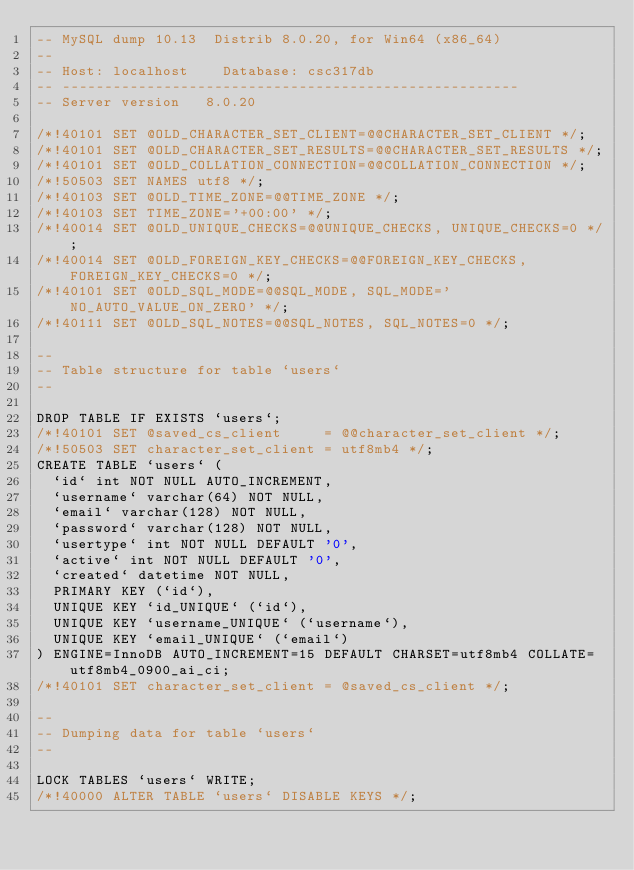Convert code to text. <code><loc_0><loc_0><loc_500><loc_500><_SQL_>-- MySQL dump 10.13  Distrib 8.0.20, for Win64 (x86_64)
--
-- Host: localhost    Database: csc317db
-- ------------------------------------------------------
-- Server version	8.0.20

/*!40101 SET @OLD_CHARACTER_SET_CLIENT=@@CHARACTER_SET_CLIENT */;
/*!40101 SET @OLD_CHARACTER_SET_RESULTS=@@CHARACTER_SET_RESULTS */;
/*!40101 SET @OLD_COLLATION_CONNECTION=@@COLLATION_CONNECTION */;
/*!50503 SET NAMES utf8 */;
/*!40103 SET @OLD_TIME_ZONE=@@TIME_ZONE */;
/*!40103 SET TIME_ZONE='+00:00' */;
/*!40014 SET @OLD_UNIQUE_CHECKS=@@UNIQUE_CHECKS, UNIQUE_CHECKS=0 */;
/*!40014 SET @OLD_FOREIGN_KEY_CHECKS=@@FOREIGN_KEY_CHECKS, FOREIGN_KEY_CHECKS=0 */;
/*!40101 SET @OLD_SQL_MODE=@@SQL_MODE, SQL_MODE='NO_AUTO_VALUE_ON_ZERO' */;
/*!40111 SET @OLD_SQL_NOTES=@@SQL_NOTES, SQL_NOTES=0 */;

--
-- Table structure for table `users`
--

DROP TABLE IF EXISTS `users`;
/*!40101 SET @saved_cs_client     = @@character_set_client */;
/*!50503 SET character_set_client = utf8mb4 */;
CREATE TABLE `users` (
  `id` int NOT NULL AUTO_INCREMENT,
  `username` varchar(64) NOT NULL,
  `email` varchar(128) NOT NULL,
  `password` varchar(128) NOT NULL,
  `usertype` int NOT NULL DEFAULT '0',
  `active` int NOT NULL DEFAULT '0',
  `created` datetime NOT NULL,
  PRIMARY KEY (`id`),
  UNIQUE KEY `id_UNIQUE` (`id`),
  UNIQUE KEY `username_UNIQUE` (`username`),
  UNIQUE KEY `email_UNIQUE` (`email`)
) ENGINE=InnoDB AUTO_INCREMENT=15 DEFAULT CHARSET=utf8mb4 COLLATE=utf8mb4_0900_ai_ci;
/*!40101 SET character_set_client = @saved_cs_client */;

--
-- Dumping data for table `users`
--

LOCK TABLES `users` WRITE;
/*!40000 ALTER TABLE `users` DISABLE KEYS */;</code> 